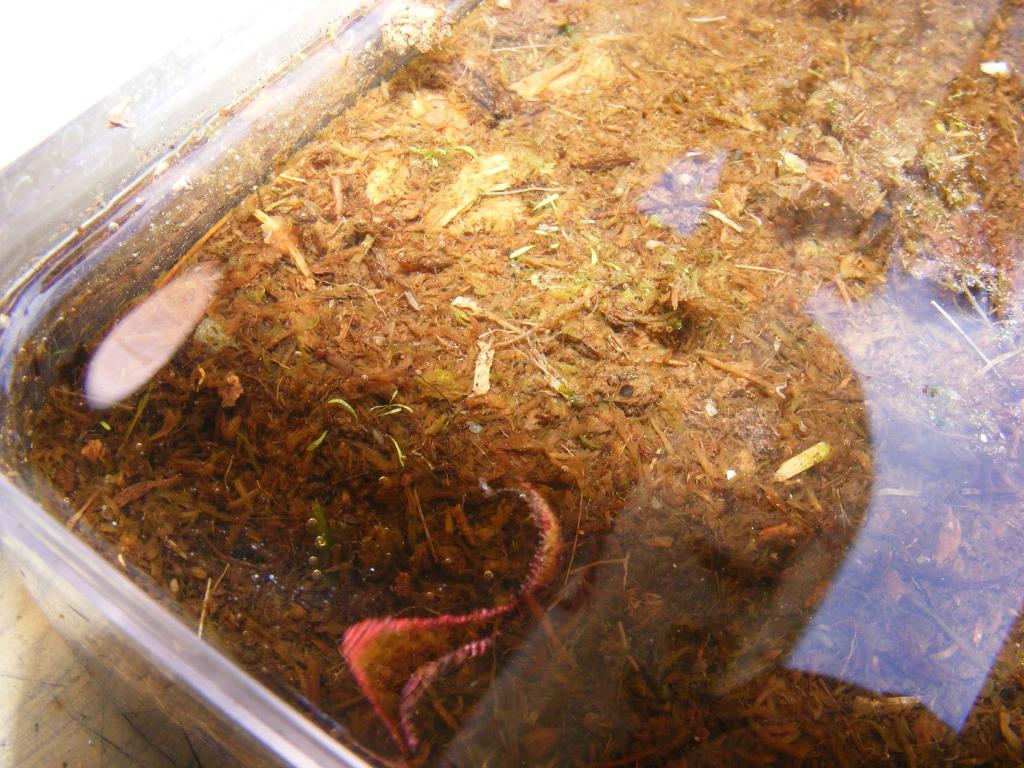Can you describe this image briefly? In this picture I can see storage box. I can see manure. 